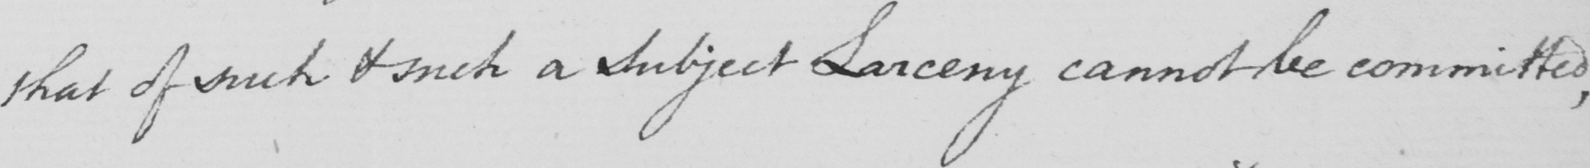Can you read and transcribe this handwriting? , that of such & such a Subject Larceny cannot be committed , 